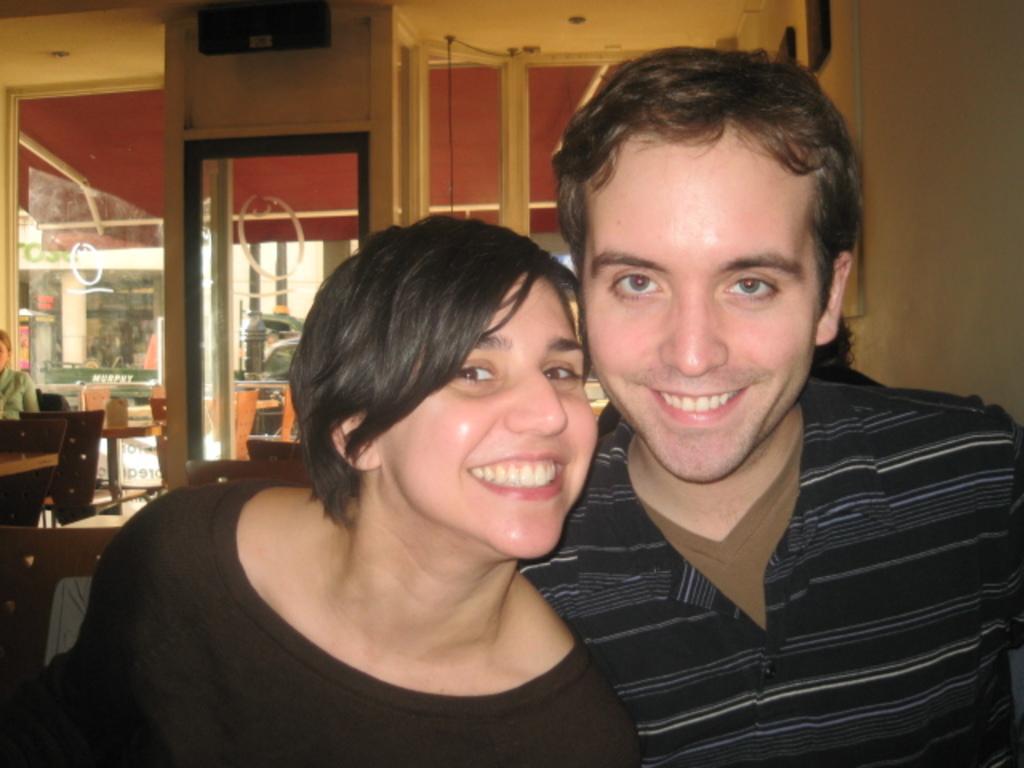Describe this image in one or two sentences. In the image we can see a woman and a man wearing clothes and they are smiling. Behind them, we can see there are many chairs and glass windows. In the background, we can see a person sitting and wearing clothes. There is a wall and frame stick to the wall. 